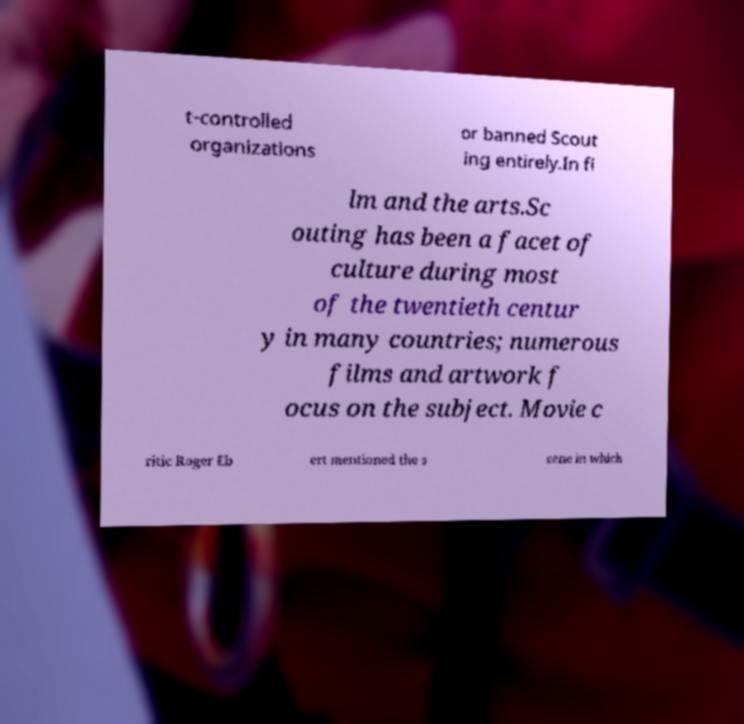Could you extract and type out the text from this image? t-controlled organizations or banned Scout ing entirely.In fi lm and the arts.Sc outing has been a facet of culture during most of the twentieth centur y in many countries; numerous films and artwork f ocus on the subject. Movie c ritic Roger Eb ert mentioned the s cene in which 